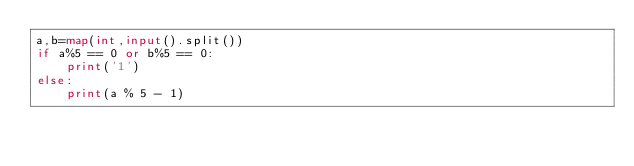Convert code to text. <code><loc_0><loc_0><loc_500><loc_500><_Python_>a,b=map(int,input().split())
if a%5 == 0 or b%5 == 0:
    print('1')
else:
    print(a % 5 - 1)

</code> 